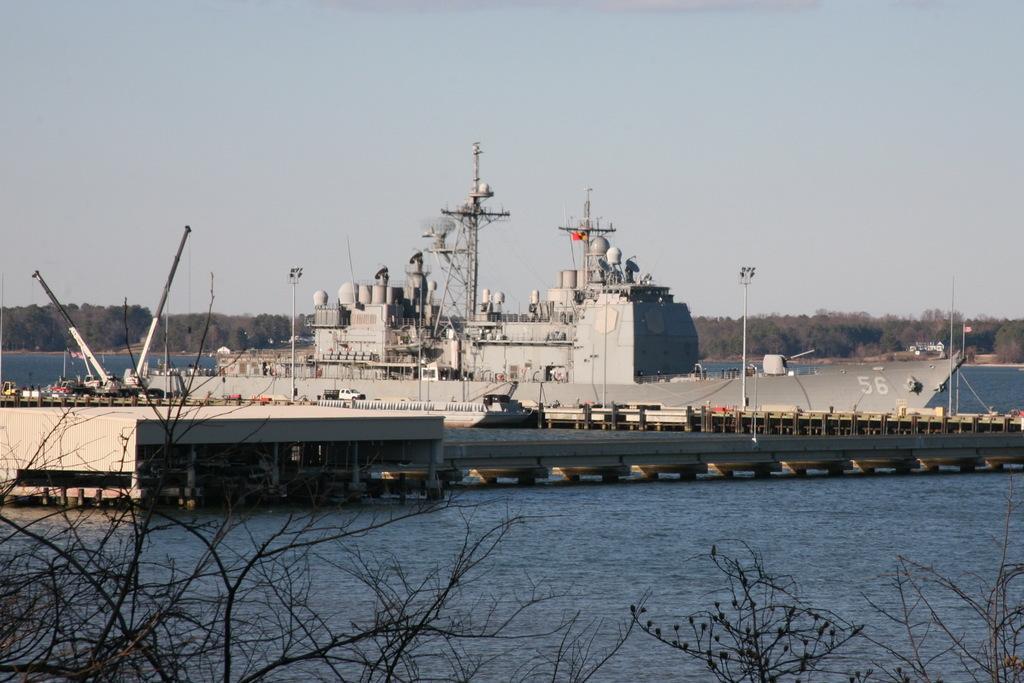Can you describe this image briefly? In this image we can see a ship on the water, there is a tower and light poles on the ship, there is a bridge and dried trees and in the background there are trees and sky. 